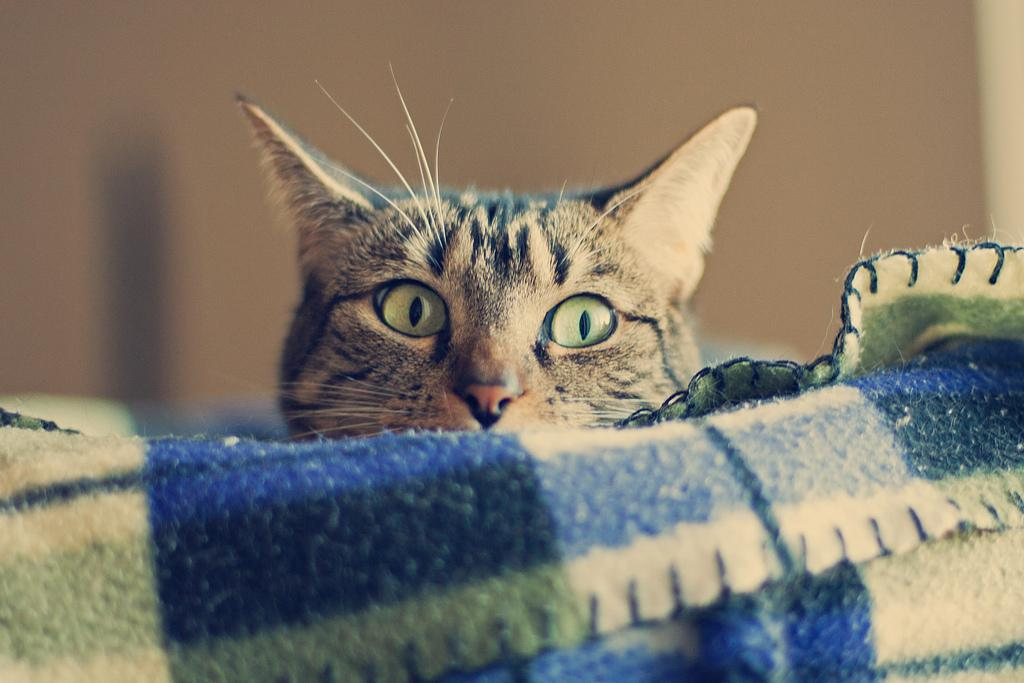What type of animal is in the image? There is a cat in the image. What object is also present in the image? There is a cloth in the image. Can you describe the background of the image? The background of the image is blurry. How many passengers are visible in the image? There are no passengers present in the image; it features a cat and a cloth. What level of the building is the image taken from? The image does not depict a building or any specific level, as it only shows a cat and a cloth. 